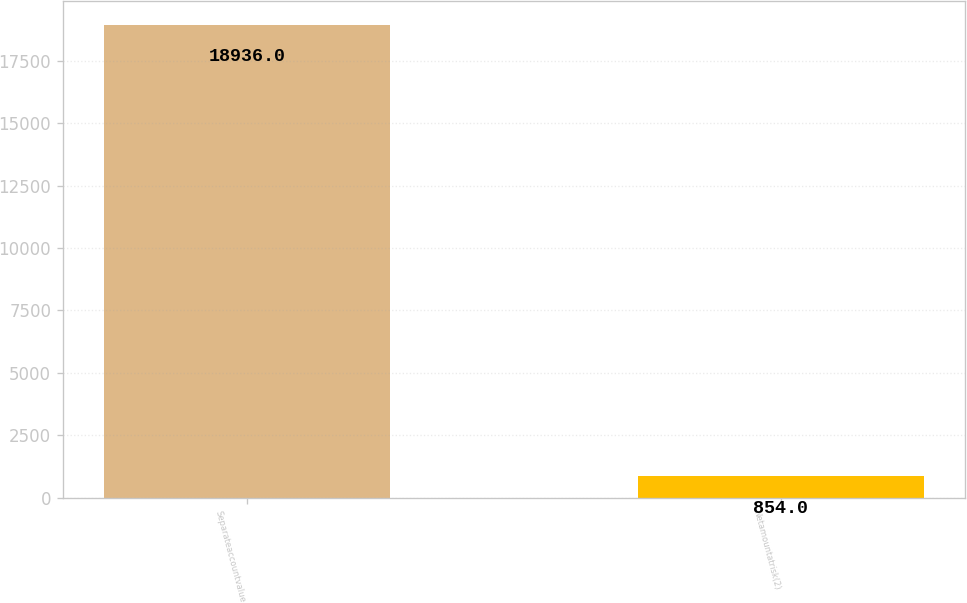Convert chart to OTSL. <chart><loc_0><loc_0><loc_500><loc_500><bar_chart><fcel>Separateaccountvalue<fcel>Netamountatrisk(2)<nl><fcel>18936<fcel>854<nl></chart> 